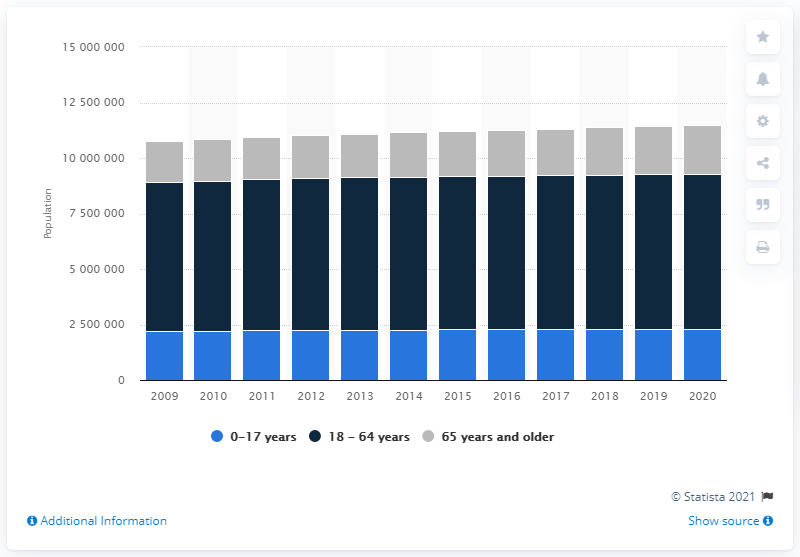Draw attention to some important aspects in this diagram. In 2020, there were 231,2040 people younger than 18 years old in Belgium. In 2020, there were approximately 2,204,478 Belgians who were 65 years or older. 